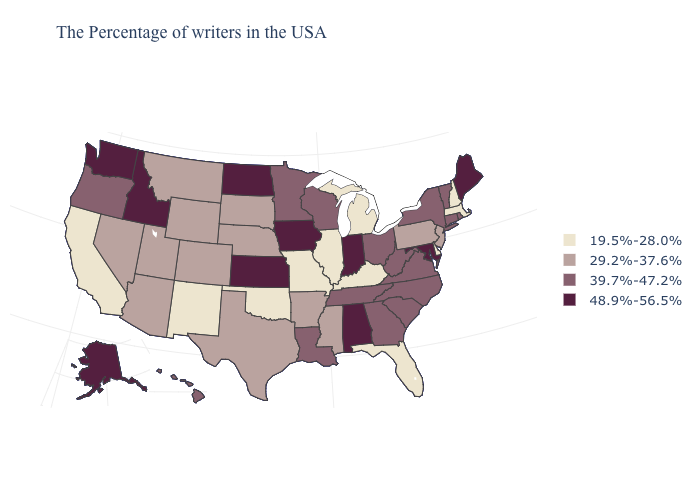Does Minnesota have a higher value than Kansas?
Keep it brief. No. How many symbols are there in the legend?
Concise answer only. 4. Among the states that border Washington , which have the highest value?
Keep it brief. Idaho. Does Iowa have a higher value than Washington?
Concise answer only. No. What is the value of Alaska?
Concise answer only. 48.9%-56.5%. Which states have the lowest value in the Northeast?
Be succinct. Massachusetts, New Hampshire. Among the states that border Texas , which have the lowest value?
Short answer required. Oklahoma, New Mexico. Name the states that have a value in the range 29.2%-37.6%?
Answer briefly. New Jersey, Pennsylvania, Mississippi, Arkansas, Nebraska, Texas, South Dakota, Wyoming, Colorado, Utah, Montana, Arizona, Nevada. Does the map have missing data?
Keep it brief. No. Name the states that have a value in the range 19.5%-28.0%?
Answer briefly. Massachusetts, New Hampshire, Delaware, Florida, Michigan, Kentucky, Illinois, Missouri, Oklahoma, New Mexico, California. Does Idaho have the highest value in the USA?
Give a very brief answer. Yes. Does Indiana have the highest value in the MidWest?
Quick response, please. Yes. Which states have the lowest value in the USA?
Concise answer only. Massachusetts, New Hampshire, Delaware, Florida, Michigan, Kentucky, Illinois, Missouri, Oklahoma, New Mexico, California. Name the states that have a value in the range 39.7%-47.2%?
Give a very brief answer. Rhode Island, Vermont, Connecticut, New York, Virginia, North Carolina, South Carolina, West Virginia, Ohio, Georgia, Tennessee, Wisconsin, Louisiana, Minnesota, Oregon, Hawaii. Name the states that have a value in the range 29.2%-37.6%?
Answer briefly. New Jersey, Pennsylvania, Mississippi, Arkansas, Nebraska, Texas, South Dakota, Wyoming, Colorado, Utah, Montana, Arizona, Nevada. 